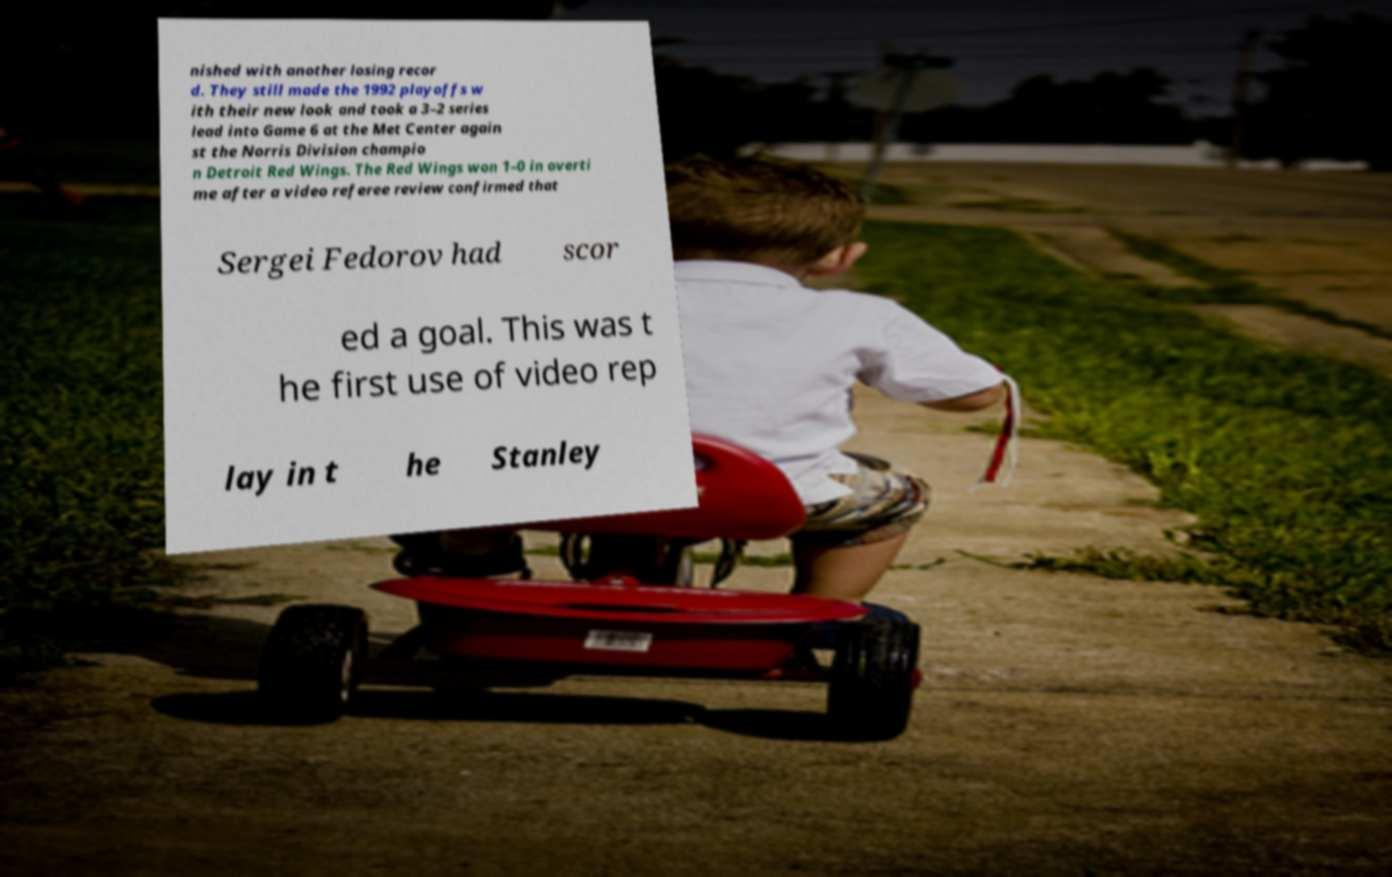Can you accurately transcribe the text from the provided image for me? nished with another losing recor d. They still made the 1992 playoffs w ith their new look and took a 3–2 series lead into Game 6 at the Met Center again st the Norris Division champio n Detroit Red Wings. The Red Wings won 1–0 in overti me after a video referee review confirmed that Sergei Fedorov had scor ed a goal. This was t he first use of video rep lay in t he Stanley 